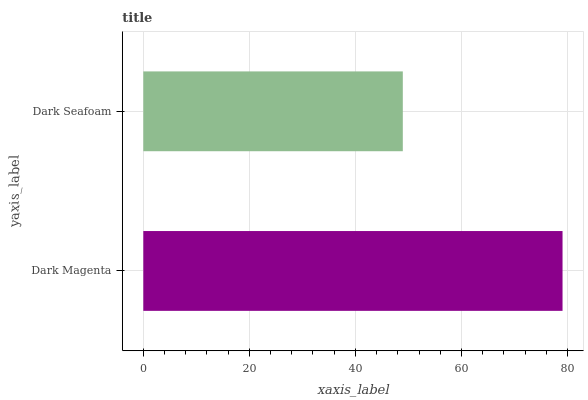Is Dark Seafoam the minimum?
Answer yes or no. Yes. Is Dark Magenta the maximum?
Answer yes or no. Yes. Is Dark Seafoam the maximum?
Answer yes or no. No. Is Dark Magenta greater than Dark Seafoam?
Answer yes or no. Yes. Is Dark Seafoam less than Dark Magenta?
Answer yes or no. Yes. Is Dark Seafoam greater than Dark Magenta?
Answer yes or no. No. Is Dark Magenta less than Dark Seafoam?
Answer yes or no. No. Is Dark Magenta the high median?
Answer yes or no. Yes. Is Dark Seafoam the low median?
Answer yes or no. Yes. Is Dark Seafoam the high median?
Answer yes or no. No. Is Dark Magenta the low median?
Answer yes or no. No. 